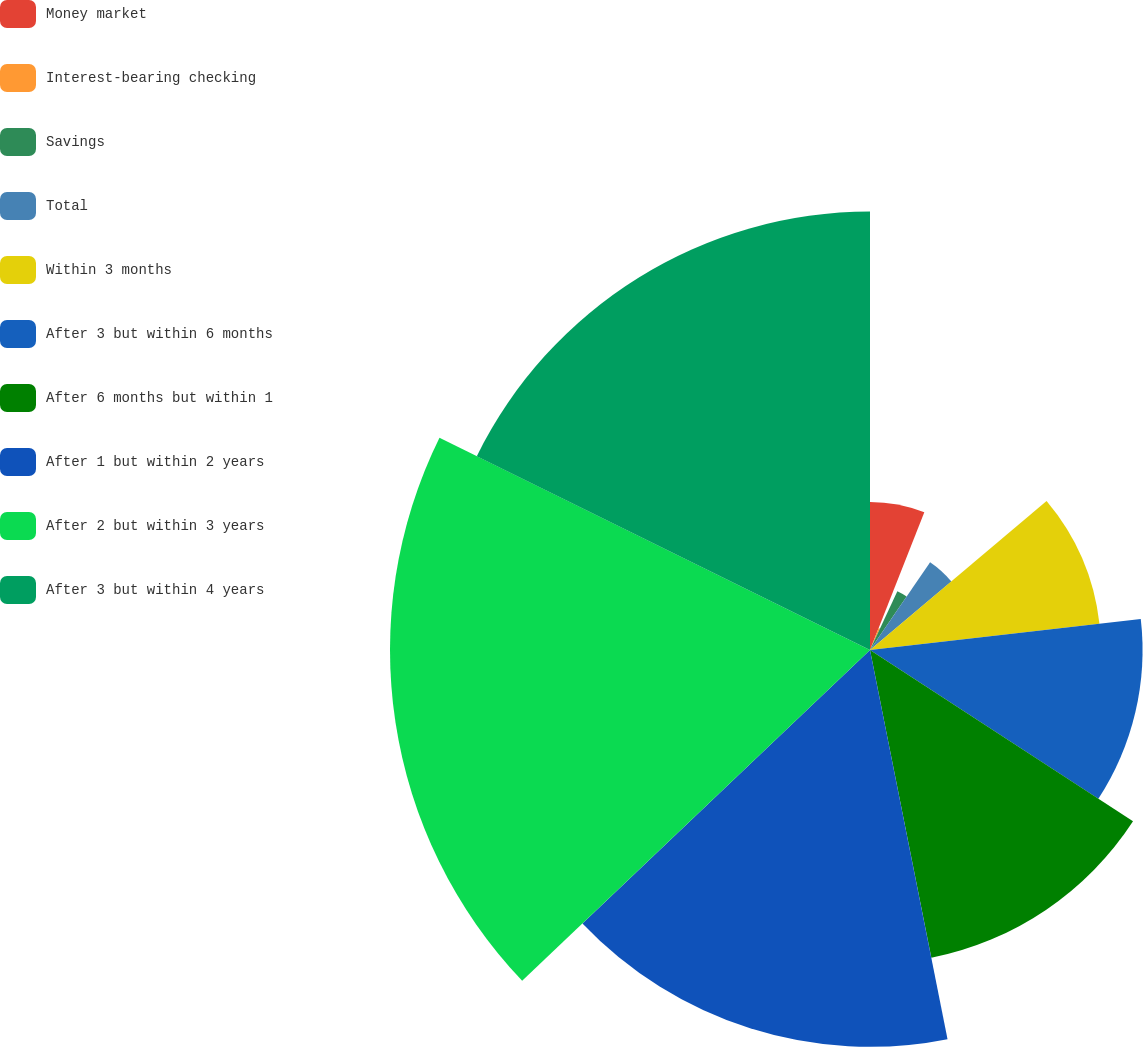Convert chart to OTSL. <chart><loc_0><loc_0><loc_500><loc_500><pie_chart><fcel>Money market<fcel>Interest-bearing checking<fcel>Savings<fcel>Total<fcel>Within 3 months<fcel>After 3 but within 6 months<fcel>After 6 months but within 1<fcel>After 1 but within 2 years<fcel>After 2 but within 3 years<fcel>After 3 but within 4 years<nl><fcel>5.98%<fcel>0.95%<fcel>2.62%<fcel>4.3%<fcel>9.33%<fcel>11.01%<fcel>12.68%<fcel>16.03%<fcel>19.39%<fcel>17.71%<nl></chart> 